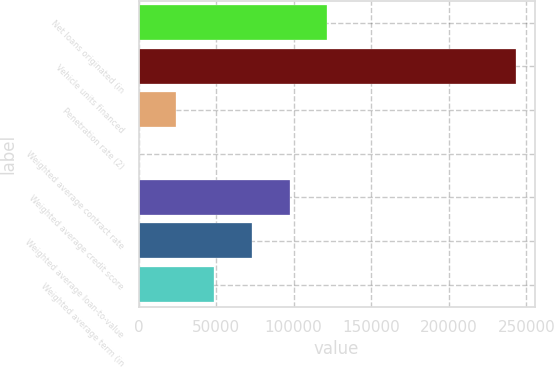<chart> <loc_0><loc_0><loc_500><loc_500><bar_chart><fcel>Net loans originated (in<fcel>Vehicle units financed<fcel>Penetration rate (2)<fcel>Weighted average contract rate<fcel>Weighted average credit score<fcel>Weighted average loan-to-value<fcel>Weighted average term (in<nl><fcel>121636<fcel>243264<fcel>24332.8<fcel>7.1<fcel>97309.9<fcel>72984.2<fcel>48658.5<nl></chart> 